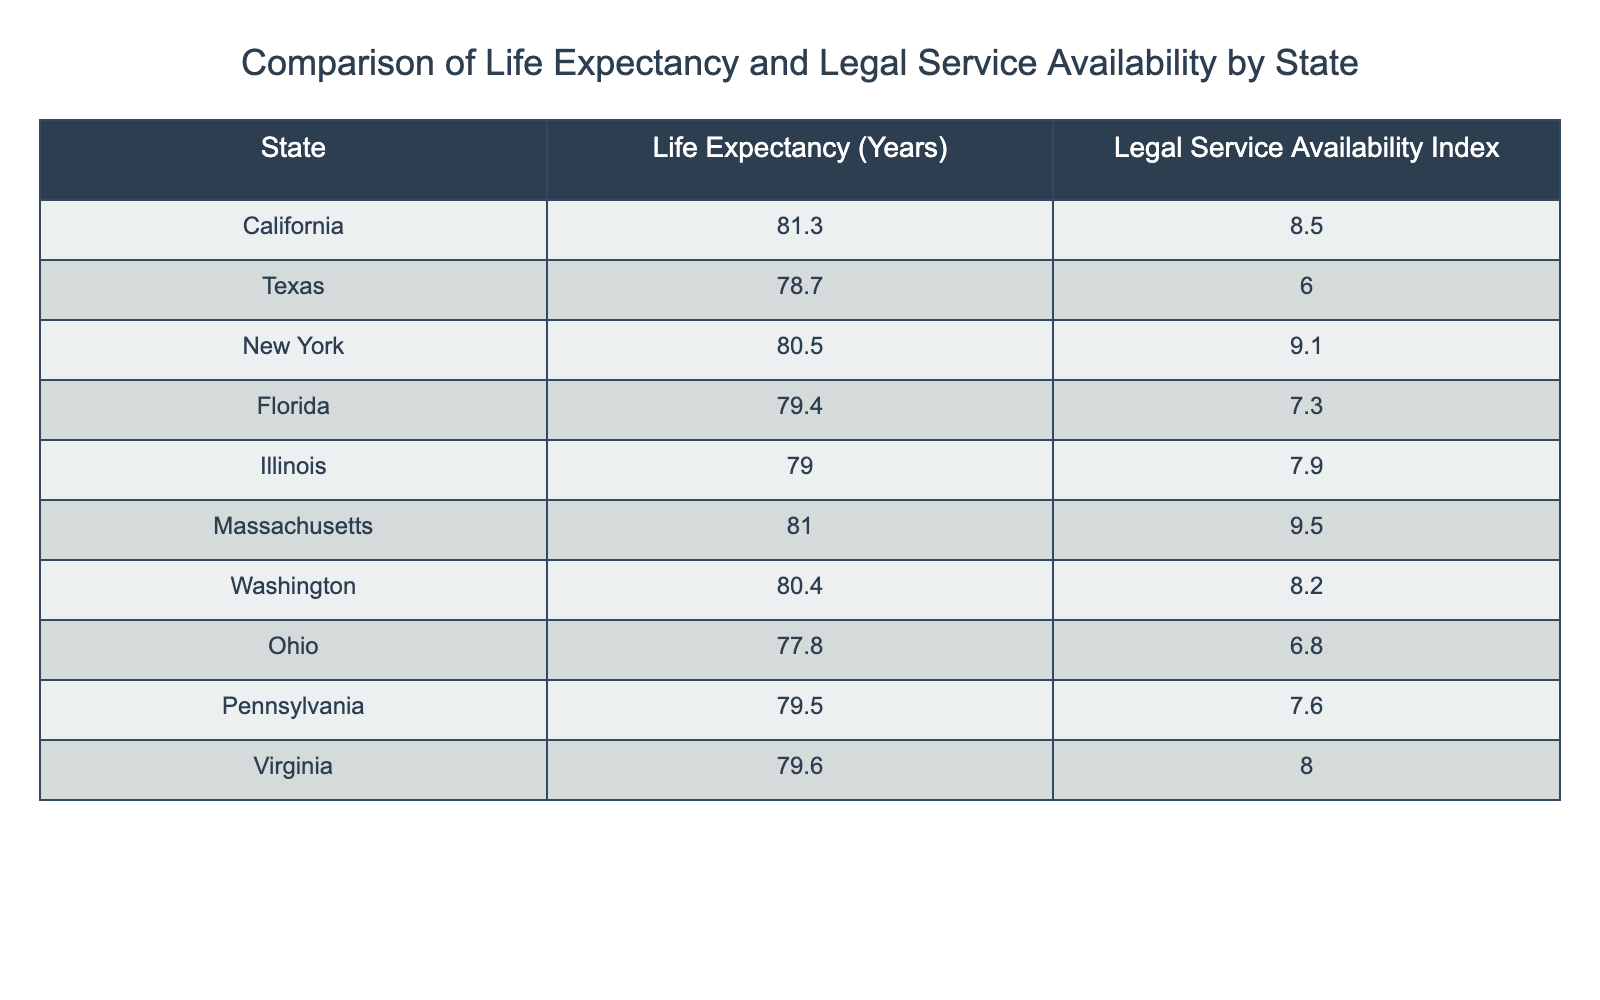What is the life expectancy in California? The table lists California's life expectancy as 81.3 years. This value can be found directly next to the state name in the table.
Answer: 81.3 years Which state has the highest Legal Service Availability Index? By inspecting the table, Massachusetts has the highest Legal Service Availability Index at 9.5. This is determined by comparing the values across all states.
Answer: Massachusetts What is the average life expectancy for the states listed? To find the average, first sum the life expectancies: (81.3 + 78.7 + 80.5 + 79.4 + 79.0 + 81.0 + 80.4 + 77.8 + 79.5 + 79.6) = 790.8. Then, divide by the number of states (10): 790.8 / 10 = 79.08.
Answer: 79.08 years Is the Legal Service Availability Index higher in New York than in Texas? New York's Legal Service Availability Index is 9.1, while Texas's is 6.0. Since 9.1 is greater than 6.0, the answer is yes.
Answer: Yes What is the difference in life expectancy between the state with the highest and the lowest? The state with the highest life expectancy is California (81.3 years) and the lowest is Ohio (77.8 years). The difference is calculated as 81.3 - 77.8 = 3.5 years.
Answer: 3.5 years How many states have a Legal Service Availability Index below 8? Checking the table, the states with an index below 8 are Texas (6.0), Ohio (6.8), and Florida (7.3). This accounts for 3 states.
Answer: 3 states Does Virginia have a higher life expectancy than Pennsylvania? Virginia's life expectancy is 79.6 years and Pennsylvania's is 79.5 years. Since 79.6 is greater than 79.5, the answer is yes.
Answer: Yes Which state has a life expectancy closest to the average calculated earlier? The average life expectancy calculated earlier is 79.08 years. The closest value in the table is Pennsylvania with 79.5 years. Checking other states confirms this is nearest.
Answer: Pennsylvania 